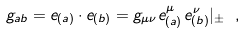<formula> <loc_0><loc_0><loc_500><loc_500>g _ { a b } = e _ { ( a ) } \cdot e _ { ( b ) } = g _ { \mu \nu } e ^ { \mu } _ { ( a ) } \, e ^ { \nu } _ { ( b ) } | _ { \pm } \ ,</formula> 